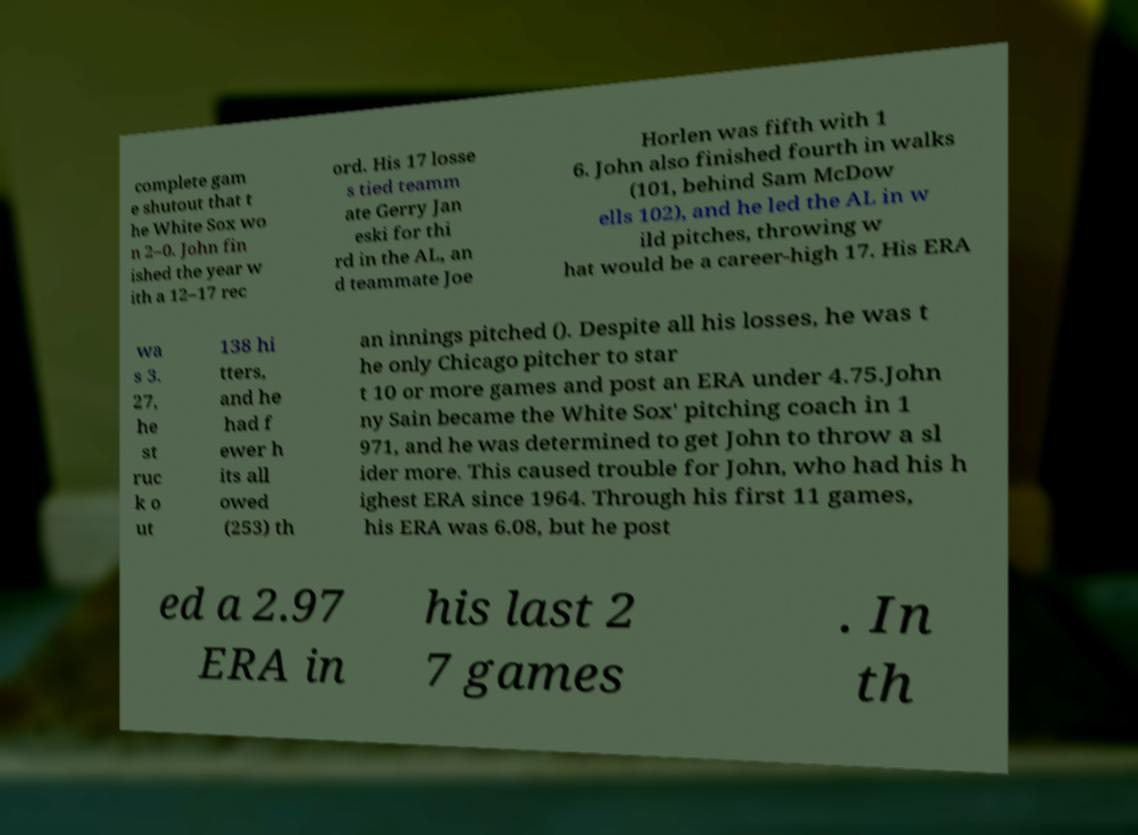Can you read and provide the text displayed in the image?This photo seems to have some interesting text. Can you extract and type it out for me? complete gam e shutout that t he White Sox wo n 2–0. John fin ished the year w ith a 12–17 rec ord. His 17 losse s tied teamm ate Gerry Jan eski for thi rd in the AL, an d teammate Joe Horlen was fifth with 1 6. John also finished fourth in walks (101, behind Sam McDow ells 102), and he led the AL in w ild pitches, throwing w hat would be a career-high 17. His ERA wa s 3. 27, he st ruc k o ut 138 hi tters, and he had f ewer h its all owed (253) th an innings pitched (). Despite all his losses, he was t he only Chicago pitcher to star t 10 or more games and post an ERA under 4.75.John ny Sain became the White Sox' pitching coach in 1 971, and he was determined to get John to throw a sl ider more. This caused trouble for John, who had his h ighest ERA since 1964. Through his first 11 games, his ERA was 6.08, but he post ed a 2.97 ERA in his last 2 7 games . In th 